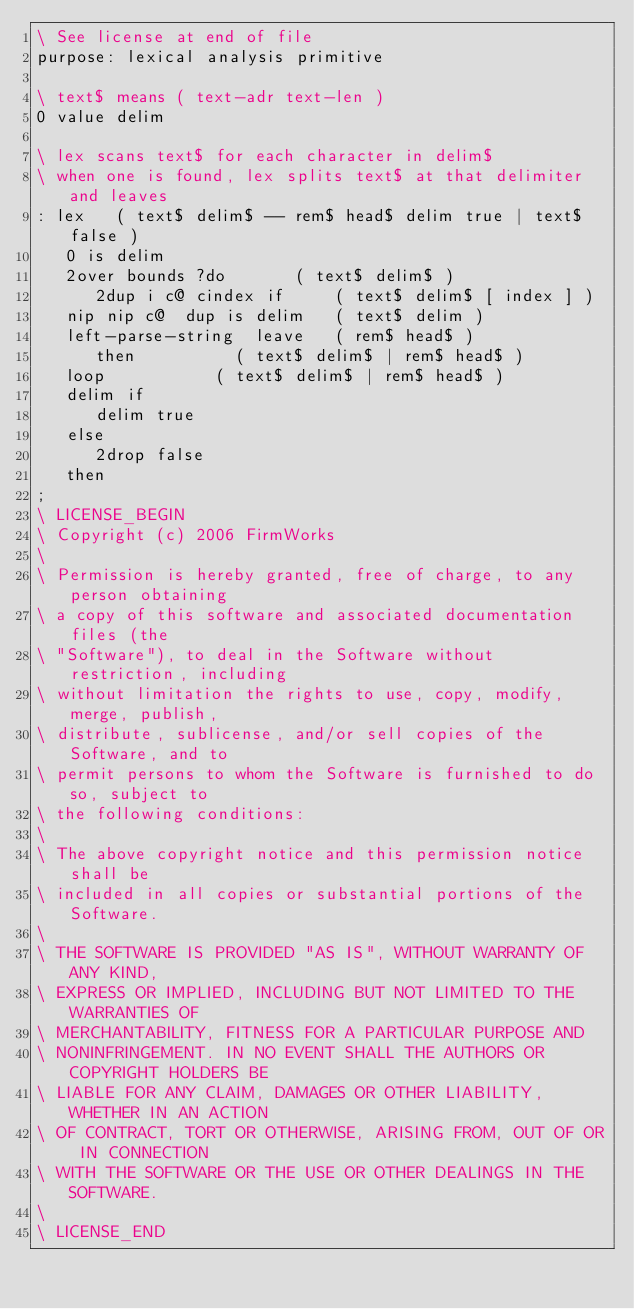Convert code to text. <code><loc_0><loc_0><loc_500><loc_500><_Forth_>\ See license at end of file
purpose: lexical analysis primitive

\ text$ means ( text-adr text-len )
0 value delim

\ lex scans text$ for each character in delim$
\ when one is found, lex splits text$ at that delimiter and leaves
: lex   ( text$ delim$ -- rem$ head$ delim true | text$ false )
   0 is delim
   2over bounds ?do				( text$ delim$ )
      2dup i c@ cindex if			( text$ delim$ [ index ] )
	 nip nip c@  dup is delim		( text$ delim )
	 left-parse-string  leave		( rem$ head$ )
      then					( text$ delim$ | rem$ head$ )
   loop						( text$ delim$ | rem$ head$ )
   delim if
      delim true
   else
      2drop false
   then
;
\ LICENSE_BEGIN
\ Copyright (c) 2006 FirmWorks
\ 
\ Permission is hereby granted, free of charge, to any person obtaining
\ a copy of this software and associated documentation files (the
\ "Software"), to deal in the Software without restriction, including
\ without limitation the rights to use, copy, modify, merge, publish,
\ distribute, sublicense, and/or sell copies of the Software, and to
\ permit persons to whom the Software is furnished to do so, subject to
\ the following conditions:
\ 
\ The above copyright notice and this permission notice shall be
\ included in all copies or substantial portions of the Software.
\ 
\ THE SOFTWARE IS PROVIDED "AS IS", WITHOUT WARRANTY OF ANY KIND,
\ EXPRESS OR IMPLIED, INCLUDING BUT NOT LIMITED TO THE WARRANTIES OF
\ MERCHANTABILITY, FITNESS FOR A PARTICULAR PURPOSE AND
\ NONINFRINGEMENT. IN NO EVENT SHALL THE AUTHORS OR COPYRIGHT HOLDERS BE
\ LIABLE FOR ANY CLAIM, DAMAGES OR OTHER LIABILITY, WHETHER IN AN ACTION
\ OF CONTRACT, TORT OR OTHERWISE, ARISING FROM, OUT OF OR IN CONNECTION
\ WITH THE SOFTWARE OR THE USE OR OTHER DEALINGS IN THE SOFTWARE.
\
\ LICENSE_END
</code> 